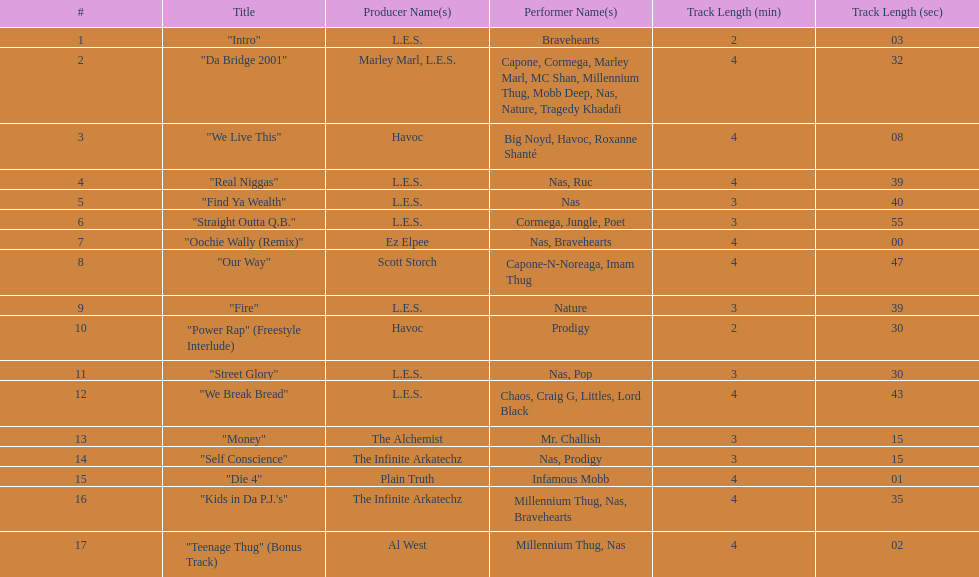Which track is longer, "money" or "die 4"? "Die 4". 